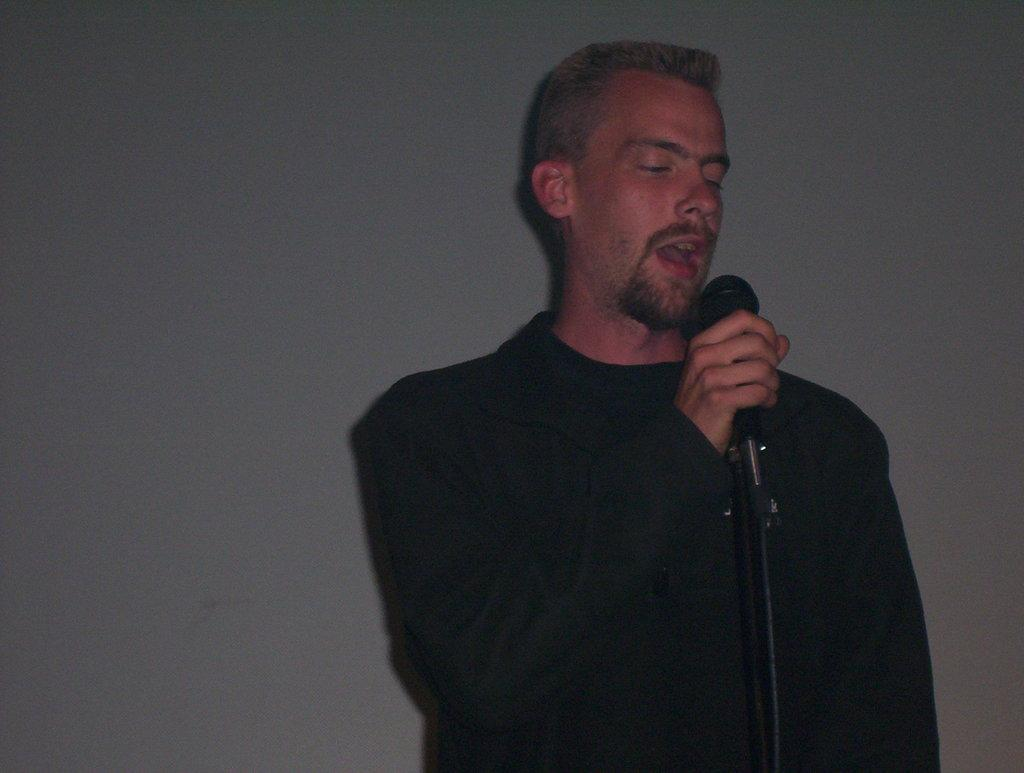Who is present in the image? There is a man in the image. What is the man wearing? The man is wearing a black dress. What is the man holding in the image? The man is holding a microphone. What can be seen in the background of the image? There is a wall in the background of the image. What type of pie is the man eating in the image? There is no pie present in the image; the man is holding a microphone. Can you tell me how many wrenches are visible in the image? There are no wrenches present in the image. 